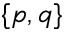Convert formula to latex. <formula><loc_0><loc_0><loc_500><loc_500>\{ p , q \}</formula> 